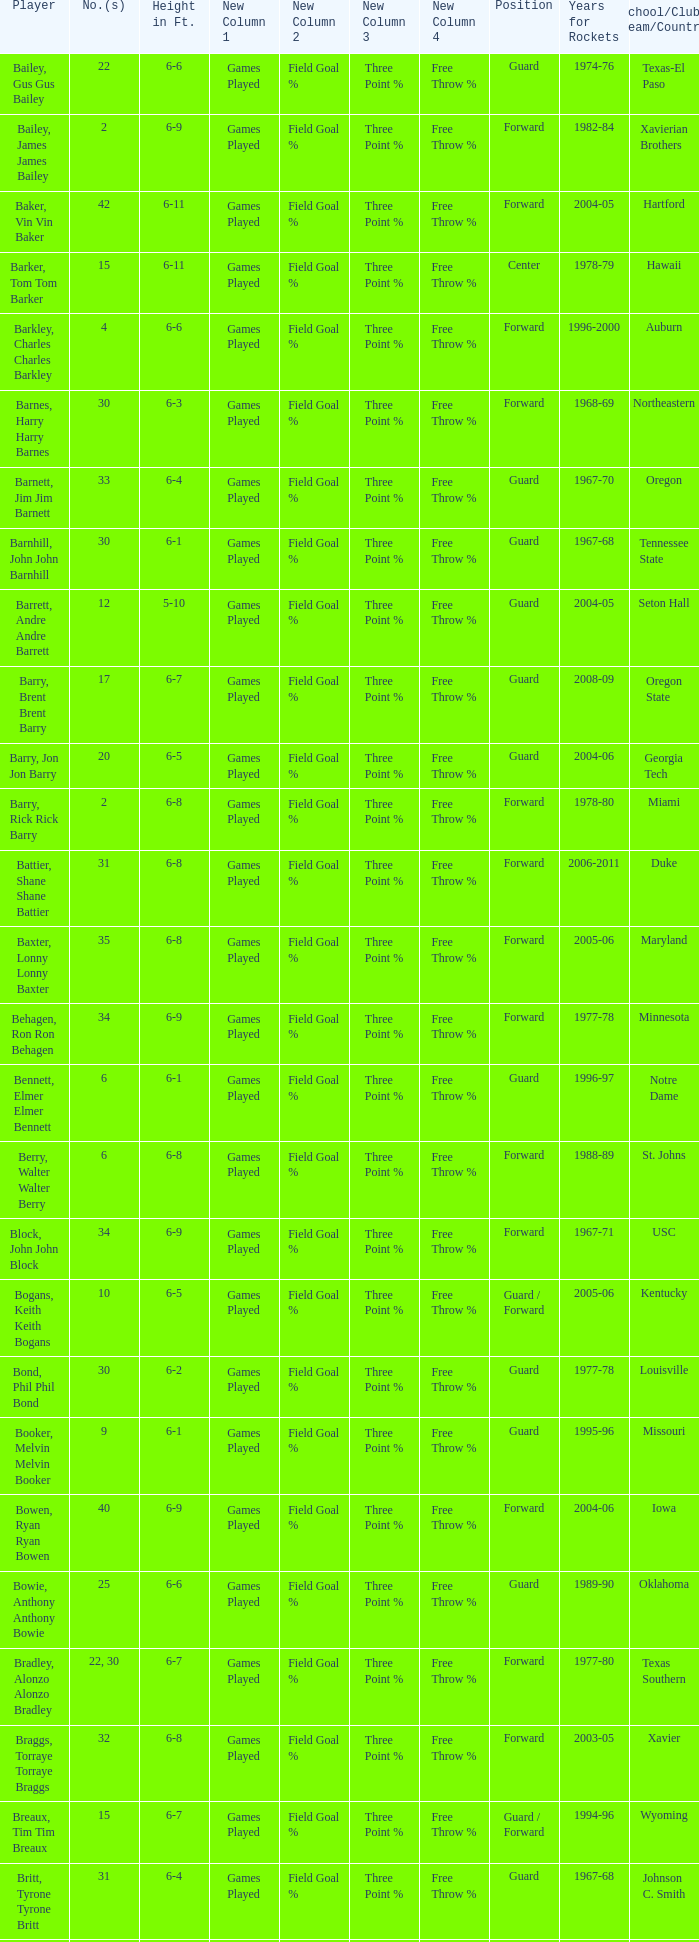What is the height of the player who attended Hartford? 6-11. 